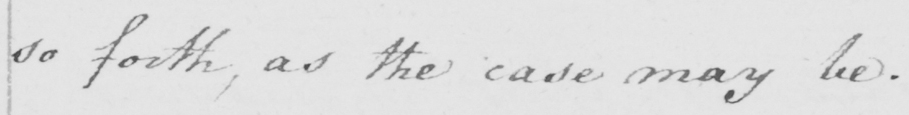What is written in this line of handwriting? so forth, as the case may be. 